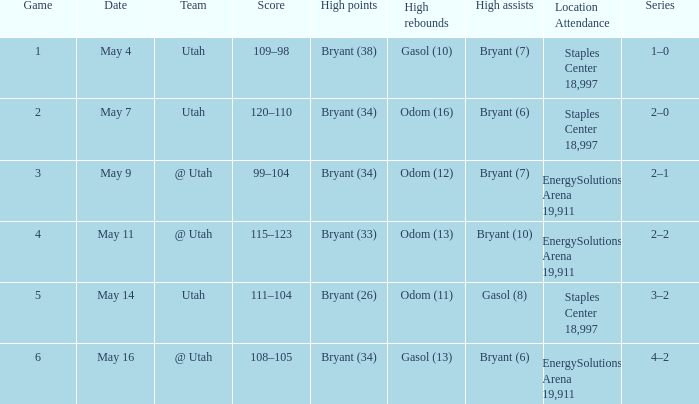What is the Series with a High rebounds with gasol (10)? 1–0. 